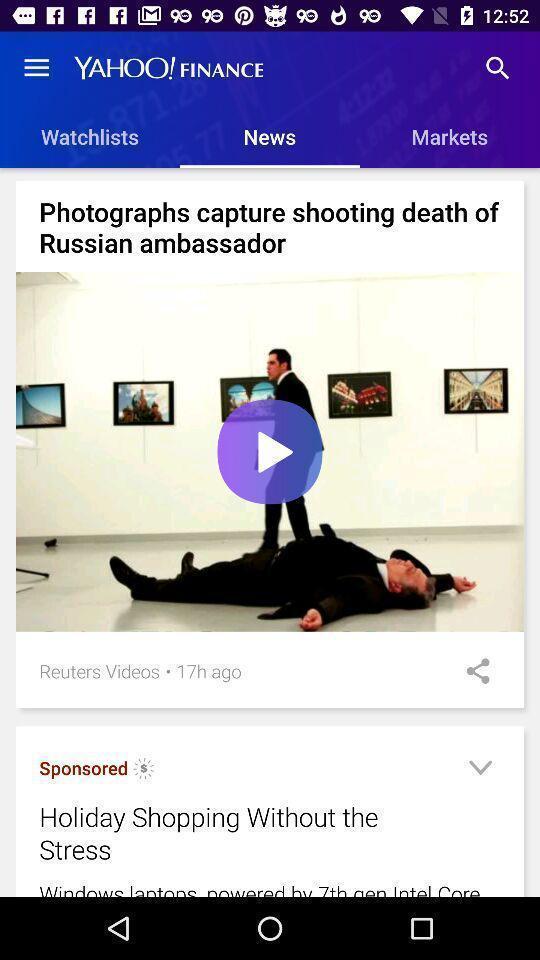Give me a narrative description of this picture. Page displaying the videos an a applications. 